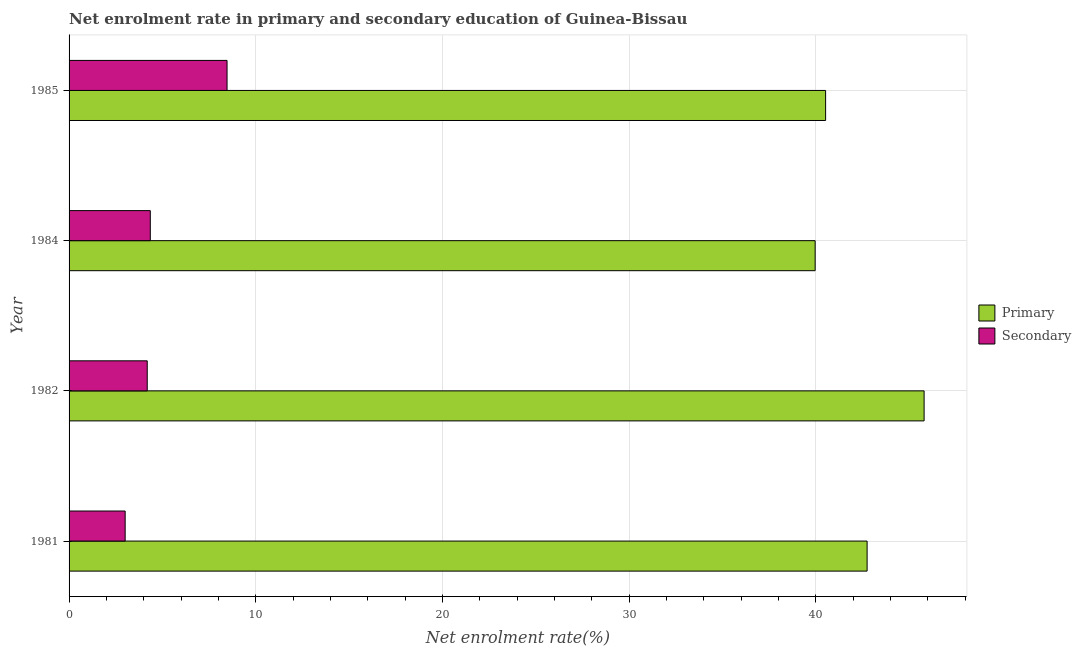How many groups of bars are there?
Make the answer very short. 4. Are the number of bars per tick equal to the number of legend labels?
Provide a succinct answer. Yes. How many bars are there on the 3rd tick from the top?
Give a very brief answer. 2. How many bars are there on the 3rd tick from the bottom?
Your response must be concise. 2. What is the label of the 3rd group of bars from the top?
Keep it short and to the point. 1982. What is the enrollment rate in primary education in 1984?
Give a very brief answer. 39.96. Across all years, what is the maximum enrollment rate in primary education?
Your answer should be compact. 45.79. Across all years, what is the minimum enrollment rate in primary education?
Ensure brevity in your answer.  39.96. In which year was the enrollment rate in primary education minimum?
Give a very brief answer. 1984. What is the total enrollment rate in secondary education in the graph?
Give a very brief answer. 20. What is the difference between the enrollment rate in primary education in 1982 and that in 1985?
Offer a very short reply. 5.28. What is the difference between the enrollment rate in primary education in 1985 and the enrollment rate in secondary education in 1981?
Offer a very short reply. 37.51. What is the average enrollment rate in primary education per year?
Provide a succinct answer. 42.25. In the year 1982, what is the difference between the enrollment rate in secondary education and enrollment rate in primary education?
Keep it short and to the point. -41.61. In how many years, is the enrollment rate in secondary education greater than 34 %?
Give a very brief answer. 0. What is the ratio of the enrollment rate in secondary education in 1981 to that in 1984?
Your answer should be compact. 0.69. Is the difference between the enrollment rate in secondary education in 1981 and 1985 greater than the difference between the enrollment rate in primary education in 1981 and 1985?
Ensure brevity in your answer.  No. What is the difference between the highest and the second highest enrollment rate in primary education?
Ensure brevity in your answer.  3.05. What is the difference between the highest and the lowest enrollment rate in primary education?
Offer a terse response. 5.84. In how many years, is the enrollment rate in primary education greater than the average enrollment rate in primary education taken over all years?
Offer a terse response. 2. What does the 2nd bar from the top in 1982 represents?
Provide a short and direct response. Primary. What does the 1st bar from the bottom in 1981 represents?
Offer a terse response. Primary. How many bars are there?
Give a very brief answer. 8. How many years are there in the graph?
Your response must be concise. 4. Are the values on the major ticks of X-axis written in scientific E-notation?
Give a very brief answer. No. Does the graph contain any zero values?
Offer a terse response. No. Where does the legend appear in the graph?
Ensure brevity in your answer.  Center right. How many legend labels are there?
Give a very brief answer. 2. What is the title of the graph?
Give a very brief answer. Net enrolment rate in primary and secondary education of Guinea-Bissau. Does "From production" appear as one of the legend labels in the graph?
Your answer should be very brief. No. What is the label or title of the X-axis?
Provide a succinct answer. Net enrolment rate(%). What is the label or title of the Y-axis?
Your response must be concise. Year. What is the Net enrolment rate(%) in Primary in 1981?
Keep it short and to the point. 42.74. What is the Net enrolment rate(%) in Secondary in 1981?
Offer a terse response. 3. What is the Net enrolment rate(%) of Primary in 1982?
Give a very brief answer. 45.79. What is the Net enrolment rate(%) of Secondary in 1982?
Offer a very short reply. 4.19. What is the Net enrolment rate(%) in Primary in 1984?
Your answer should be very brief. 39.96. What is the Net enrolment rate(%) in Secondary in 1984?
Keep it short and to the point. 4.35. What is the Net enrolment rate(%) in Primary in 1985?
Give a very brief answer. 40.52. What is the Net enrolment rate(%) of Secondary in 1985?
Offer a terse response. 8.46. Across all years, what is the maximum Net enrolment rate(%) in Primary?
Your answer should be compact. 45.79. Across all years, what is the maximum Net enrolment rate(%) in Secondary?
Provide a short and direct response. 8.46. Across all years, what is the minimum Net enrolment rate(%) of Primary?
Your answer should be very brief. 39.96. Across all years, what is the minimum Net enrolment rate(%) in Secondary?
Make the answer very short. 3. What is the total Net enrolment rate(%) of Primary in the graph?
Your answer should be very brief. 169.01. What is the total Net enrolment rate(%) of Secondary in the graph?
Keep it short and to the point. 20. What is the difference between the Net enrolment rate(%) in Primary in 1981 and that in 1982?
Offer a terse response. -3.05. What is the difference between the Net enrolment rate(%) of Secondary in 1981 and that in 1982?
Provide a succinct answer. -1.18. What is the difference between the Net enrolment rate(%) of Primary in 1981 and that in 1984?
Your answer should be very brief. 2.78. What is the difference between the Net enrolment rate(%) of Secondary in 1981 and that in 1984?
Your response must be concise. -1.35. What is the difference between the Net enrolment rate(%) of Primary in 1981 and that in 1985?
Keep it short and to the point. 2.22. What is the difference between the Net enrolment rate(%) of Secondary in 1981 and that in 1985?
Give a very brief answer. -5.46. What is the difference between the Net enrolment rate(%) of Primary in 1982 and that in 1984?
Ensure brevity in your answer.  5.84. What is the difference between the Net enrolment rate(%) of Secondary in 1982 and that in 1984?
Offer a terse response. -0.16. What is the difference between the Net enrolment rate(%) in Primary in 1982 and that in 1985?
Offer a terse response. 5.28. What is the difference between the Net enrolment rate(%) in Secondary in 1982 and that in 1985?
Your answer should be compact. -4.28. What is the difference between the Net enrolment rate(%) in Primary in 1984 and that in 1985?
Offer a terse response. -0.56. What is the difference between the Net enrolment rate(%) of Secondary in 1984 and that in 1985?
Make the answer very short. -4.11. What is the difference between the Net enrolment rate(%) in Primary in 1981 and the Net enrolment rate(%) in Secondary in 1982?
Provide a short and direct response. 38.55. What is the difference between the Net enrolment rate(%) of Primary in 1981 and the Net enrolment rate(%) of Secondary in 1984?
Your answer should be compact. 38.39. What is the difference between the Net enrolment rate(%) of Primary in 1981 and the Net enrolment rate(%) of Secondary in 1985?
Your response must be concise. 34.28. What is the difference between the Net enrolment rate(%) of Primary in 1982 and the Net enrolment rate(%) of Secondary in 1984?
Your answer should be very brief. 41.44. What is the difference between the Net enrolment rate(%) in Primary in 1982 and the Net enrolment rate(%) in Secondary in 1985?
Make the answer very short. 37.33. What is the difference between the Net enrolment rate(%) of Primary in 1984 and the Net enrolment rate(%) of Secondary in 1985?
Provide a short and direct response. 31.5. What is the average Net enrolment rate(%) of Primary per year?
Keep it short and to the point. 42.25. What is the average Net enrolment rate(%) of Secondary per year?
Provide a succinct answer. 5. In the year 1981, what is the difference between the Net enrolment rate(%) in Primary and Net enrolment rate(%) in Secondary?
Provide a succinct answer. 39.74. In the year 1982, what is the difference between the Net enrolment rate(%) in Primary and Net enrolment rate(%) in Secondary?
Your response must be concise. 41.61. In the year 1984, what is the difference between the Net enrolment rate(%) of Primary and Net enrolment rate(%) of Secondary?
Ensure brevity in your answer.  35.61. In the year 1985, what is the difference between the Net enrolment rate(%) in Primary and Net enrolment rate(%) in Secondary?
Offer a very short reply. 32.06. What is the ratio of the Net enrolment rate(%) in Primary in 1981 to that in 1982?
Offer a terse response. 0.93. What is the ratio of the Net enrolment rate(%) in Secondary in 1981 to that in 1982?
Offer a terse response. 0.72. What is the ratio of the Net enrolment rate(%) of Primary in 1981 to that in 1984?
Provide a succinct answer. 1.07. What is the ratio of the Net enrolment rate(%) in Secondary in 1981 to that in 1984?
Give a very brief answer. 0.69. What is the ratio of the Net enrolment rate(%) in Primary in 1981 to that in 1985?
Offer a very short reply. 1.05. What is the ratio of the Net enrolment rate(%) of Secondary in 1981 to that in 1985?
Your response must be concise. 0.36. What is the ratio of the Net enrolment rate(%) of Primary in 1982 to that in 1984?
Your response must be concise. 1.15. What is the ratio of the Net enrolment rate(%) of Secondary in 1982 to that in 1984?
Provide a short and direct response. 0.96. What is the ratio of the Net enrolment rate(%) in Primary in 1982 to that in 1985?
Provide a succinct answer. 1.13. What is the ratio of the Net enrolment rate(%) in Secondary in 1982 to that in 1985?
Ensure brevity in your answer.  0.49. What is the ratio of the Net enrolment rate(%) of Primary in 1984 to that in 1985?
Give a very brief answer. 0.99. What is the ratio of the Net enrolment rate(%) of Secondary in 1984 to that in 1985?
Keep it short and to the point. 0.51. What is the difference between the highest and the second highest Net enrolment rate(%) of Primary?
Ensure brevity in your answer.  3.05. What is the difference between the highest and the second highest Net enrolment rate(%) in Secondary?
Your answer should be compact. 4.11. What is the difference between the highest and the lowest Net enrolment rate(%) in Primary?
Provide a short and direct response. 5.84. What is the difference between the highest and the lowest Net enrolment rate(%) in Secondary?
Provide a succinct answer. 5.46. 